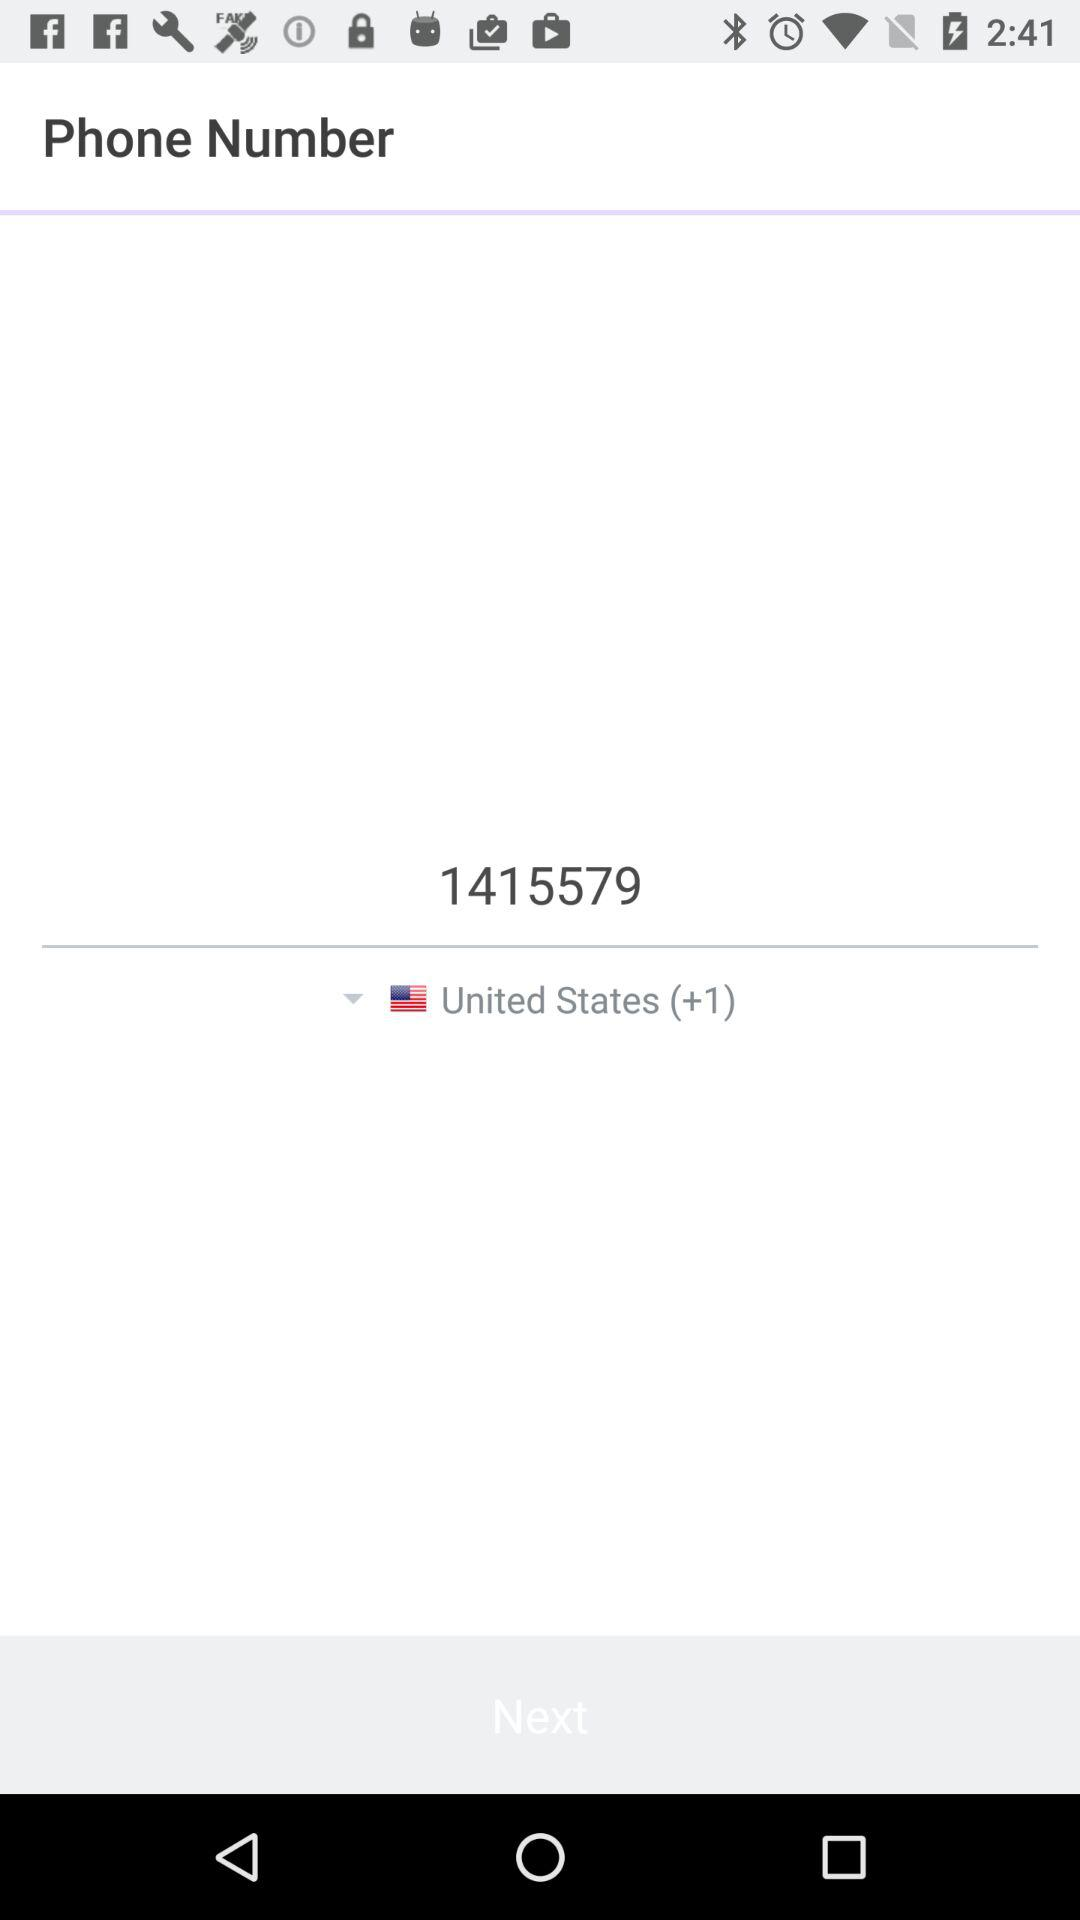What is the contact number? The contact number is 1415579. 